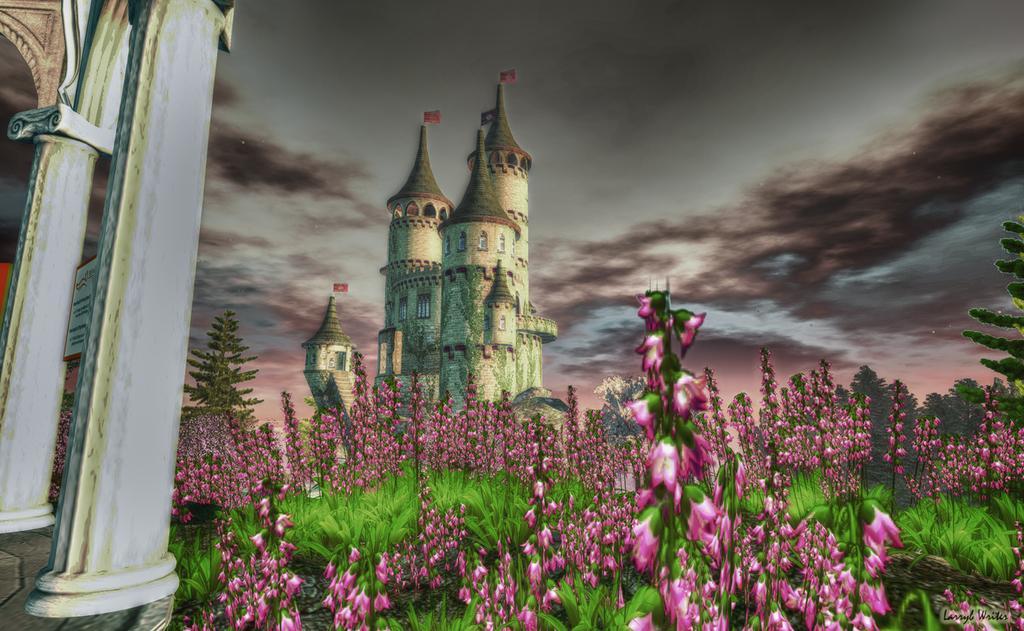Describe this image in one or two sentences. In the image there are many flower plants in the front with a castle behind it, on the left side there are pillars and above its sky with clouds, this seems to be a painting. 